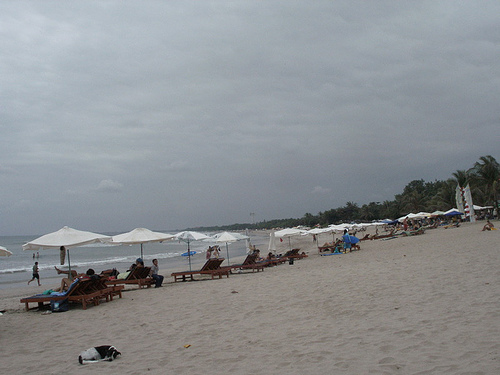<image>What are the objects in the air? There are no objects in the air in the image. What are the objects in the air? There are no objects in the air. 